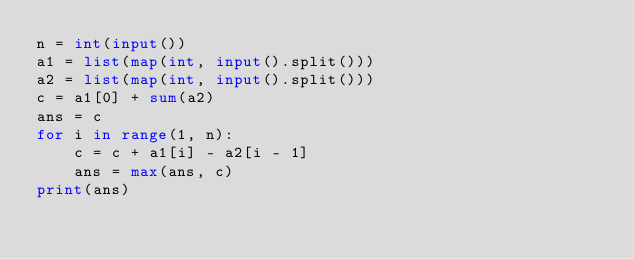<code> <loc_0><loc_0><loc_500><loc_500><_Python_>n = int(input())
a1 = list(map(int, input().split()))
a2 = list(map(int, input().split()))
c = a1[0] + sum(a2)
ans = c
for i in range(1, n):
    c = c + a1[i] - a2[i - 1]
    ans = max(ans, c)
print(ans)</code> 